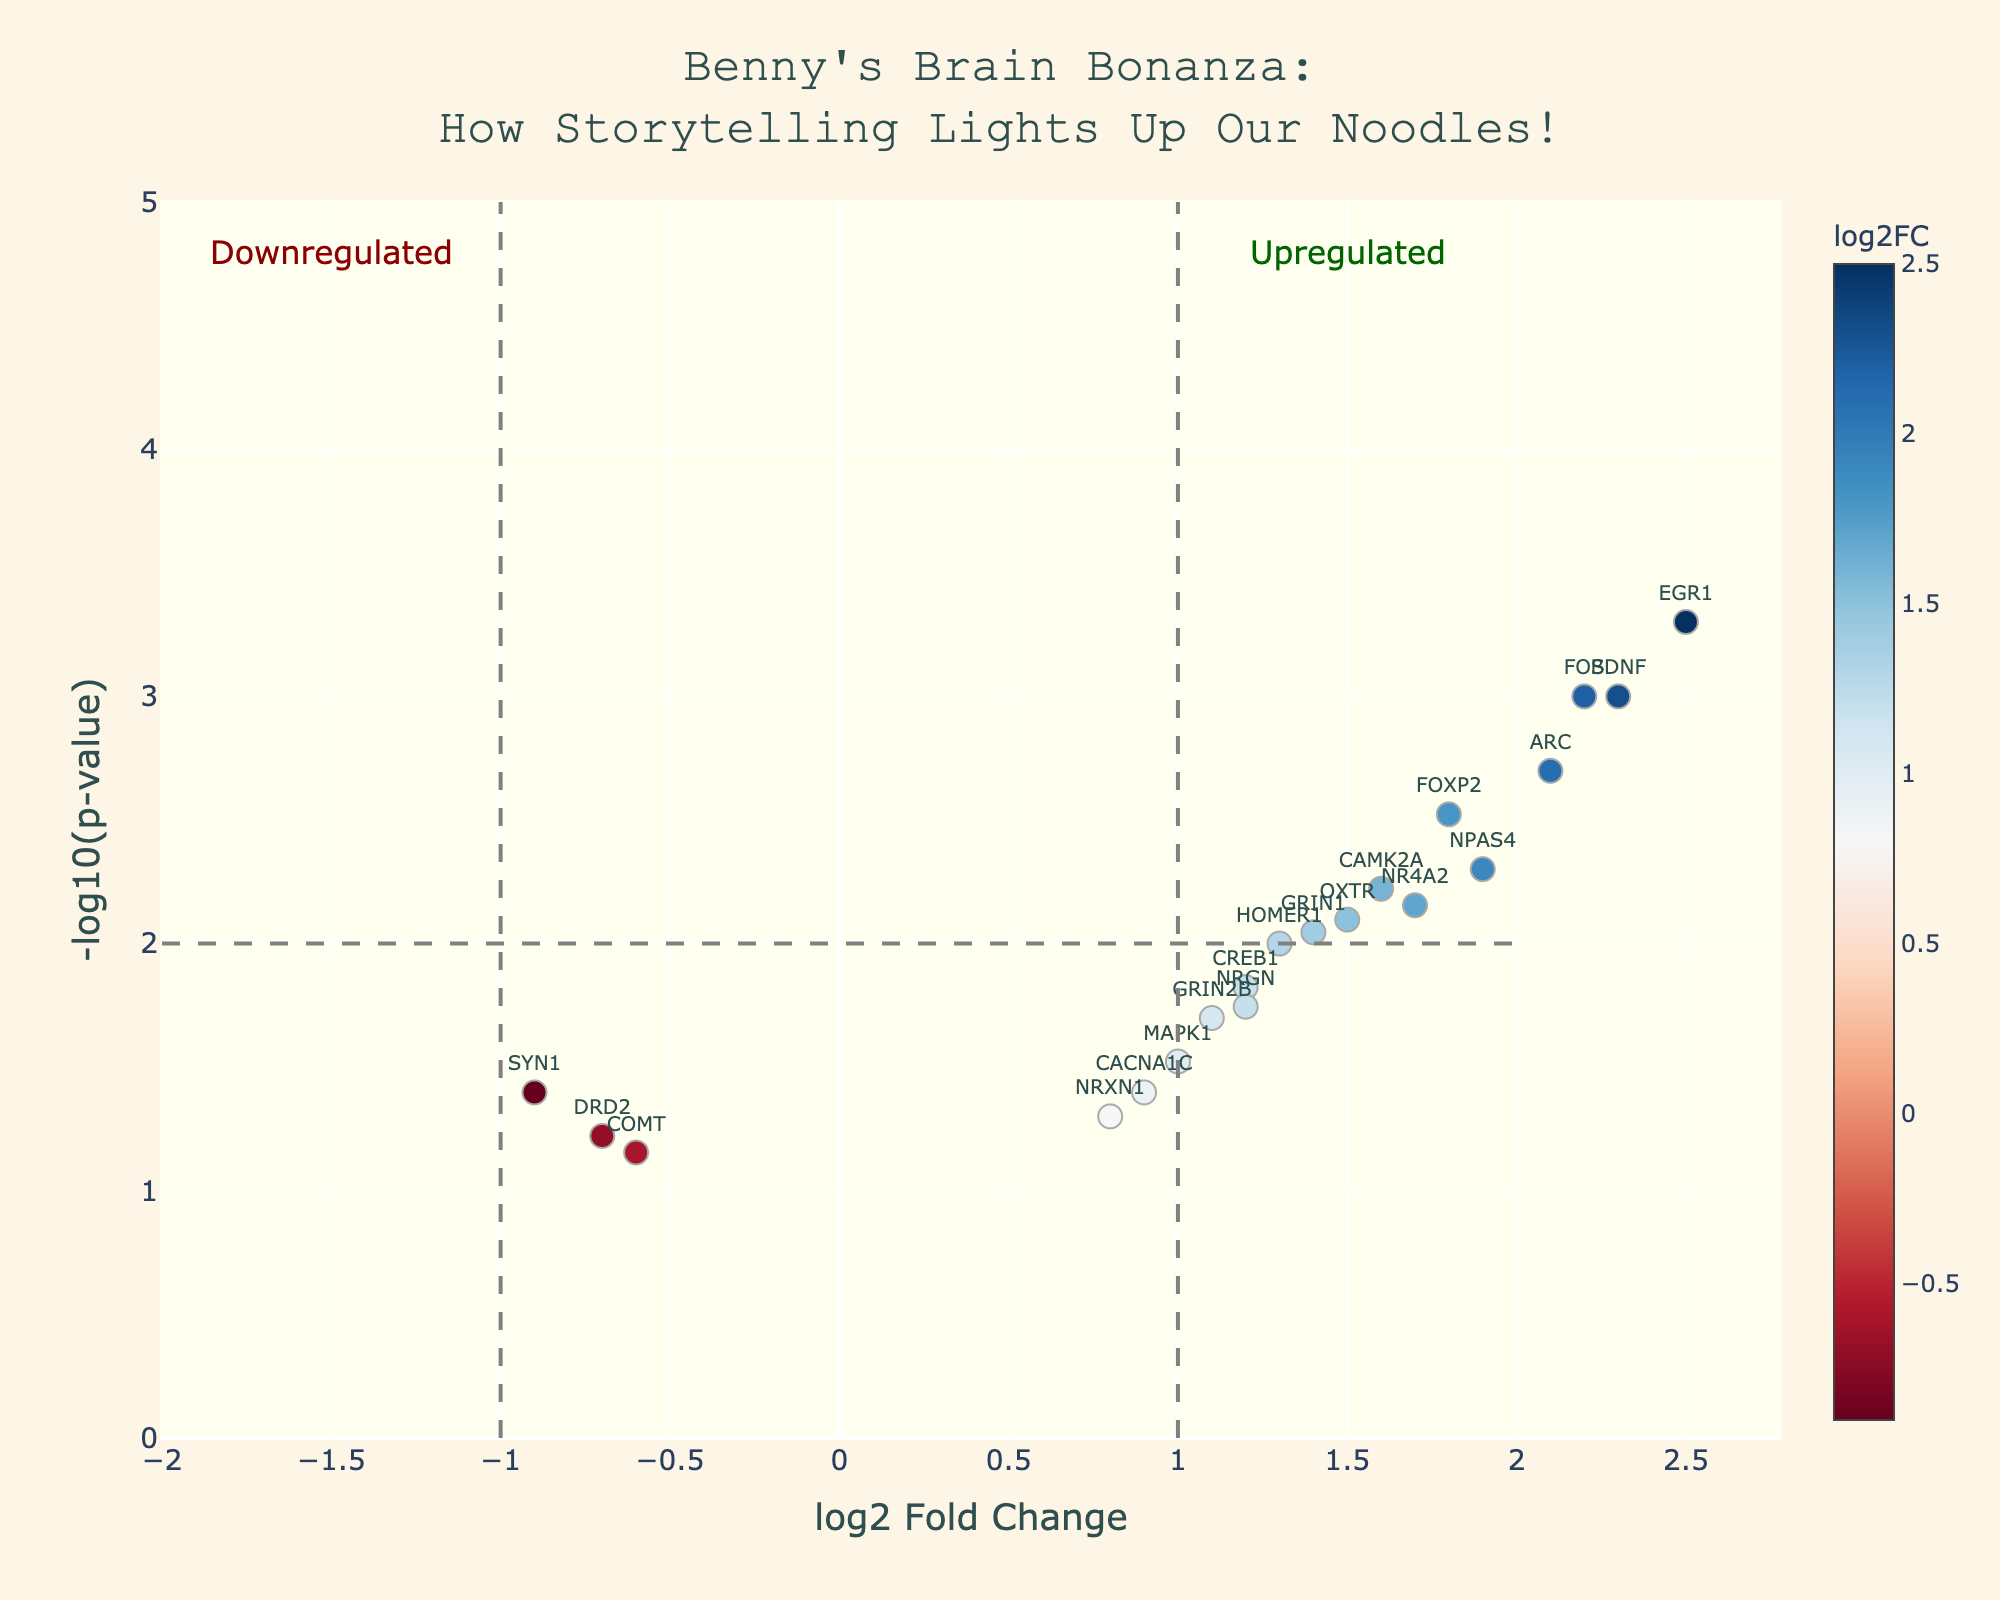What's the title of the figure? The title of the figure is typically placed at the top, center of the plot with a larger font size than the rest. Here, it reads: "Benny's Brain Bonanza: How Storytelling Lights Up Our Noodles!"
Answer: Benny's Brain Bonanza: How Storytelling Lights Up Our Noodles! What does the x-axis represent? The label of the x-axis usually indicates the type of data it represents. Here, it is labeled as "log2 Fold Change," indicating it shows the log2 fold change of gene expression.
Answer: log2 Fold Change What color indicates upregulated genes? By observing the color scale on the plot, genes with positive log2 fold change are in warmer tones, often red, which represent upregulation.
Answer: Red Which gene has the highest -log10(p-value)? To find the gene with the highest -log10(p-value), locate the point that is furthest up on the y-axis. The annotation helps us identify that gene as EGR1.
Answer: EGR1 How many genes are upregulated with a log2 fold change greater than 1? First, identify points with log2 fold change > 1 by looking at the right of the central axis and above 0. Then count these annotations: BDNF, FOXP2, ARC, NPAS4, FOS, etc.
Answer: 10 Which gene shows the greatest downregulation? Locate the point on the left side of the plot with the lowest log2 fold change. The gene annotation identifies this as SYN1.
Answer: SYN1 Are there any genes that have a p-value greater than 0.05? Look for any points below the line indicating the significance threshold of -log10(0.05). SYN1 and others above this threshold do not meet this criterion.
Answer: No Which gene has a log2 fold change of approximately 2.3 and what is its statistical significance? Locate the point annotated around x = 2.3; by the annotation, we identify it as BDNF with a p-value of 0.001.
Answer: BDNF, p-value: 0.001 What does the annotation "Upregulated" indicate? The annotation "Upregulated" is positioned on the right side of the plot and is marked in green, indicating genes with positive log2 fold change values.
Answer: Genes with positive log2 fold change Compare BDNF and SYN1 in terms of fold change and statistical significance. BDNF (log2FC = 2.3, p-value = 0.001) is upregulated, while SYN1 (log2FC = -0.9, p-value = 0.04) is downregulated. This indicates stronger upregulation and statistical significance for BDNF compared to the downregulation and significance of SYN1.
Answer: BDNF is more upregulated and statistically significant compared to SYN1 